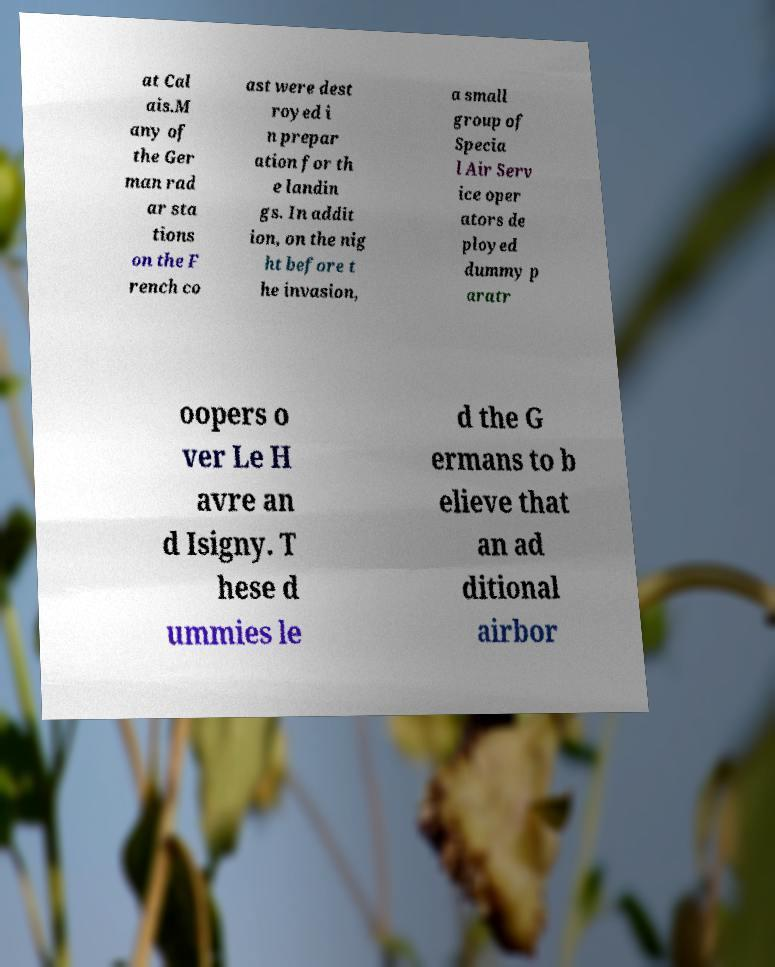I need the written content from this picture converted into text. Can you do that? at Cal ais.M any of the Ger man rad ar sta tions on the F rench co ast were dest royed i n prepar ation for th e landin gs. In addit ion, on the nig ht before t he invasion, a small group of Specia l Air Serv ice oper ators de ployed dummy p aratr oopers o ver Le H avre an d Isigny. T hese d ummies le d the G ermans to b elieve that an ad ditional airbor 